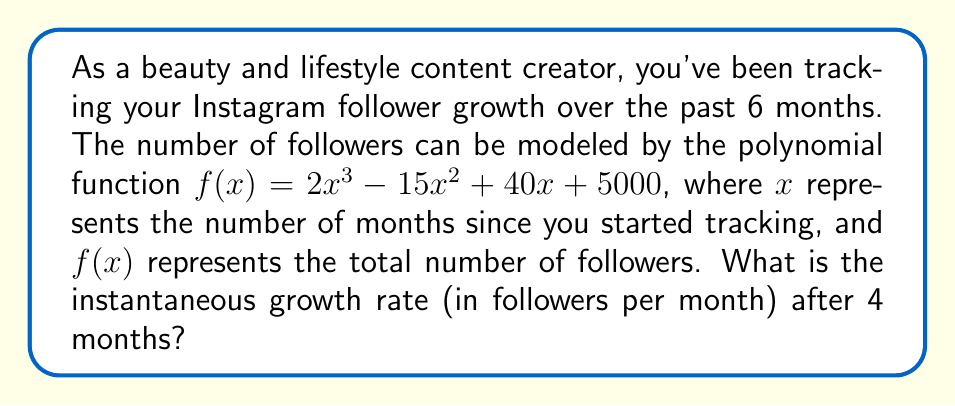Provide a solution to this math problem. To find the instantaneous growth rate after 4 months, we need to calculate the derivative of the given polynomial function and evaluate it at $x = 4$. Here's the step-by-step process:

1) The given polynomial function is:
   $f(x) = 2x^3 - 15x^2 + 40x + 5000$

2) To find the growth rate, we need to differentiate $f(x)$ with respect to $x$:
   $f'(x) = 6x^2 - 30x + 40$

3) The derivative $f'(x)$ represents the instantaneous growth rate at any given time $x$.

4) We need to evaluate $f'(x)$ at $x = 4$:
   $f'(4) = 6(4)^2 - 30(4) + 40$
   
5) Let's calculate:
   $f'(4) = 6(16) - 120 + 40$
   $f'(4) = 96 - 120 + 40$
   $f'(4) = 16$

Therefore, the instantaneous growth rate after 4 months is 16 followers per month.
Answer: 16 followers/month 